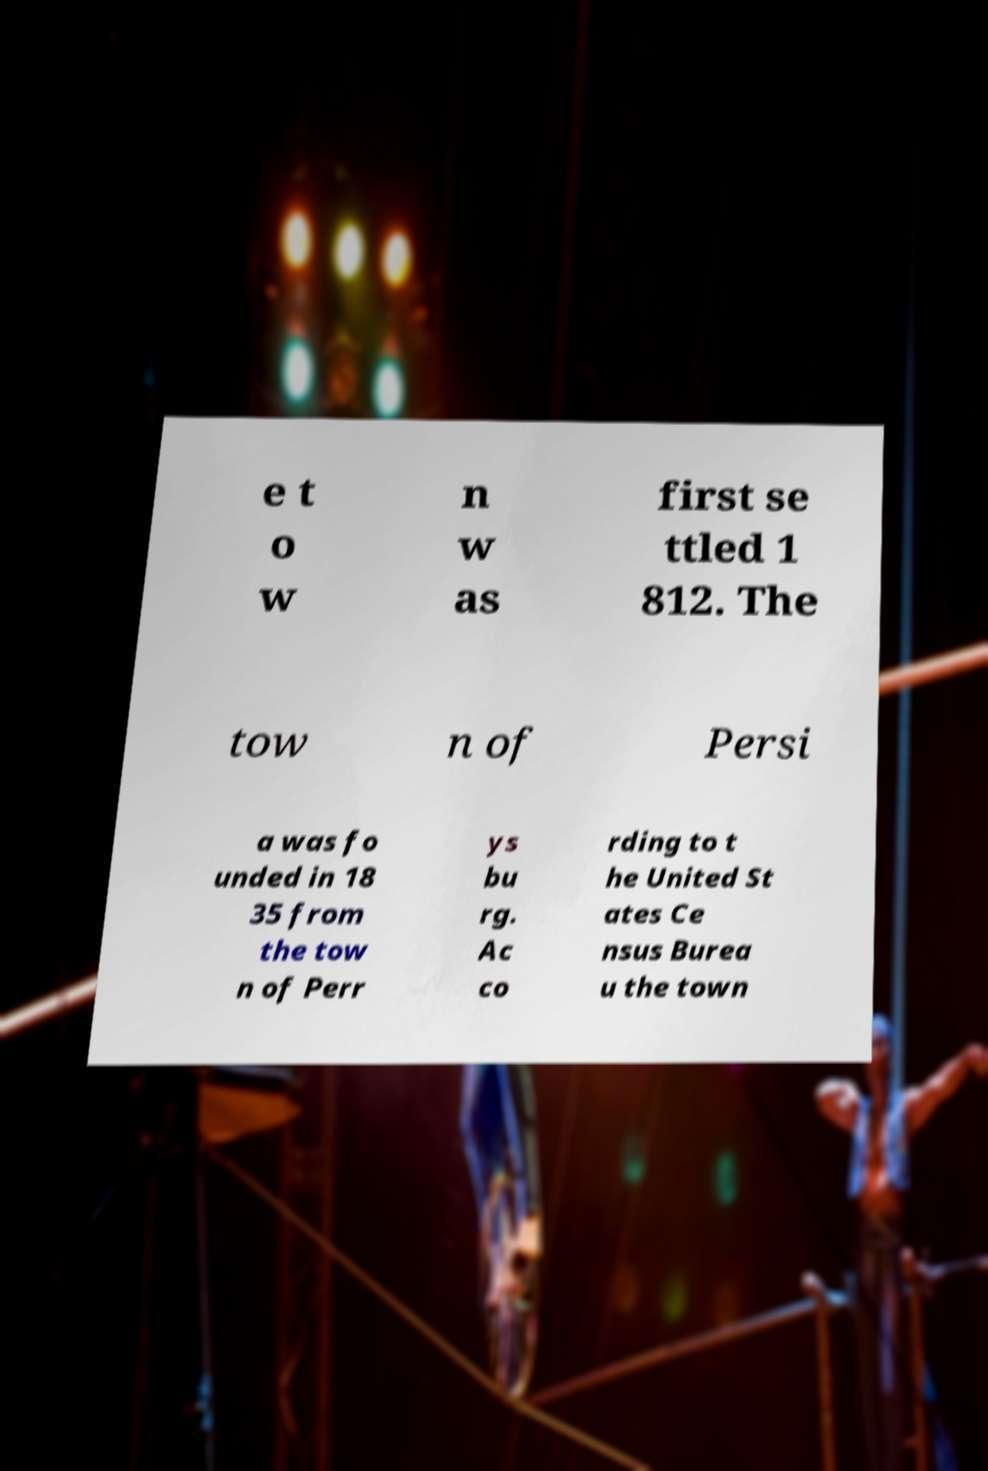I need the written content from this picture converted into text. Can you do that? e t o w n w as first se ttled 1 812. The tow n of Persi a was fo unded in 18 35 from the tow n of Perr ys bu rg. Ac co rding to t he United St ates Ce nsus Burea u the town 